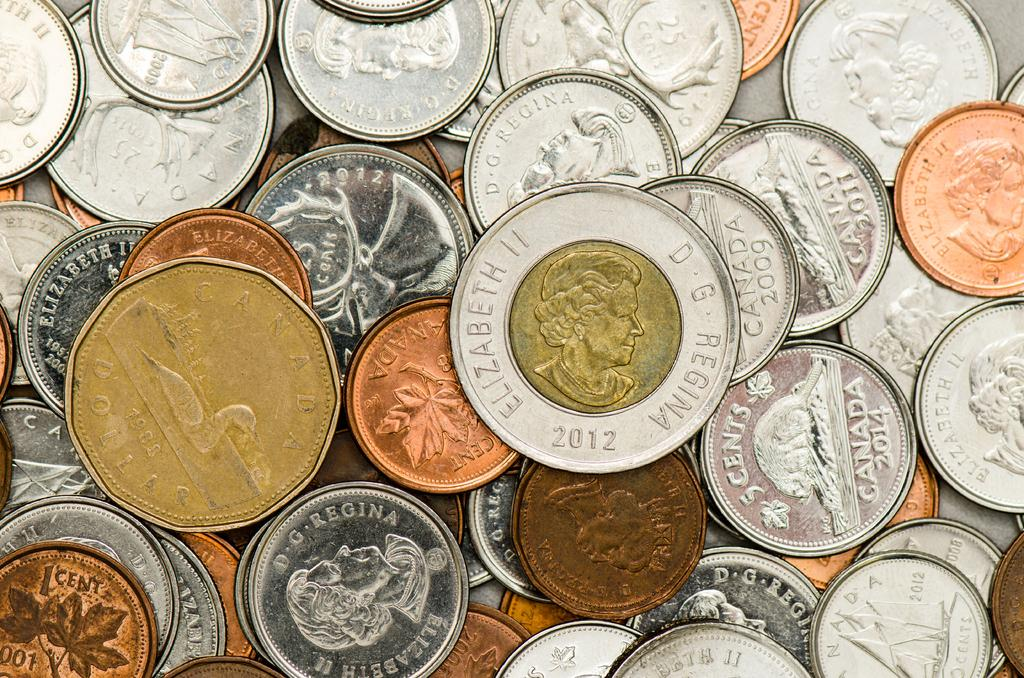<image>
Render a clear and concise summary of the photo. Coins of various colors and shapes are sitting in a pile together with a 2012 Canadian Elizabeth II sitting on top 